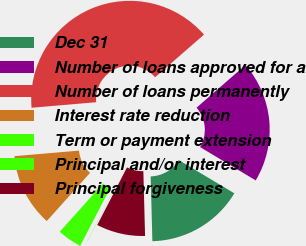Convert chart. <chart><loc_0><loc_0><loc_500><loc_500><pie_chart><fcel>Dec 31<fcel>Number of loans approved for a<fcel>Number of loans permanently<fcel>Interest rate reduction<fcel>Term or payment extension<fcel>Principal and/or interest<fcel>Principal forgiveness<nl><fcel>16.0%<fcel>19.99%<fcel>39.95%<fcel>12.0%<fcel>4.02%<fcel>0.03%<fcel>8.01%<nl></chart> 